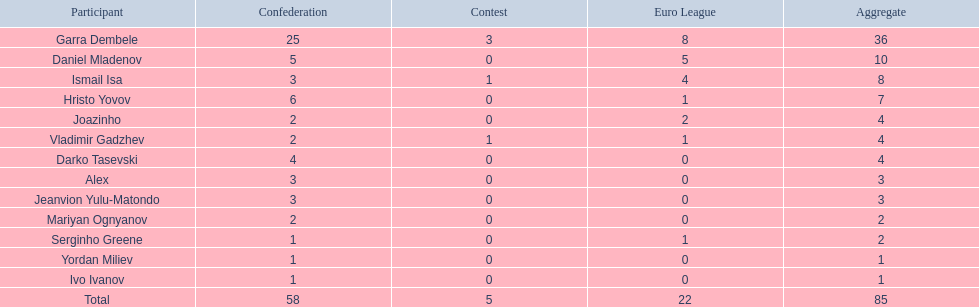What is the sum of the cup total and the europa league total? 27. 